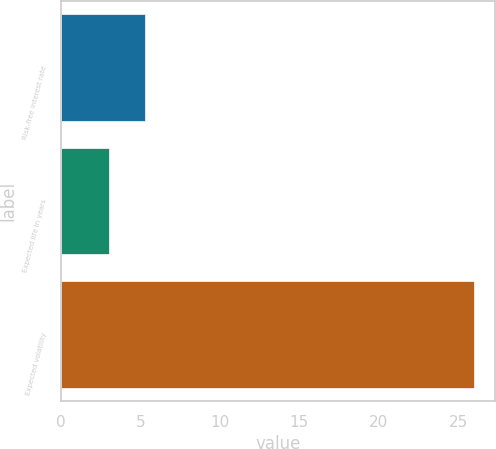Convert chart. <chart><loc_0><loc_0><loc_500><loc_500><bar_chart><fcel>Risk-free interest rate<fcel>Expected life in years<fcel>Expected volatility<nl><fcel>5.3<fcel>3<fcel>26<nl></chart> 